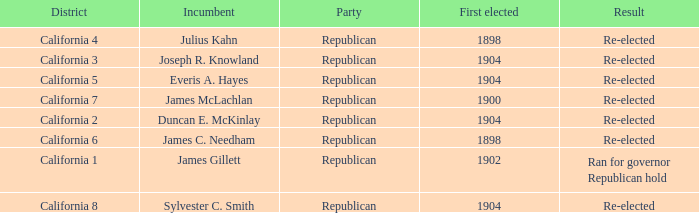Which Incumbent has a District of California 5? Everis A. Hayes. Can you give me this table as a dict? {'header': ['District', 'Incumbent', 'Party', 'First elected', 'Result'], 'rows': [['California 4', 'Julius Kahn', 'Republican', '1898', 'Re-elected'], ['California 3', 'Joseph R. Knowland', 'Republican', '1904', 'Re-elected'], ['California 5', 'Everis A. Hayes', 'Republican', '1904', 'Re-elected'], ['California 7', 'James McLachlan', 'Republican', '1900', 'Re-elected'], ['California 2', 'Duncan E. McKinlay', 'Republican', '1904', 'Re-elected'], ['California 6', 'James C. Needham', 'Republican', '1898', 'Re-elected'], ['California 1', 'James Gillett', 'Republican', '1902', 'Ran for governor Republican hold'], ['California 8', 'Sylvester C. Smith', 'Republican', '1904', 'Re-elected']]} 